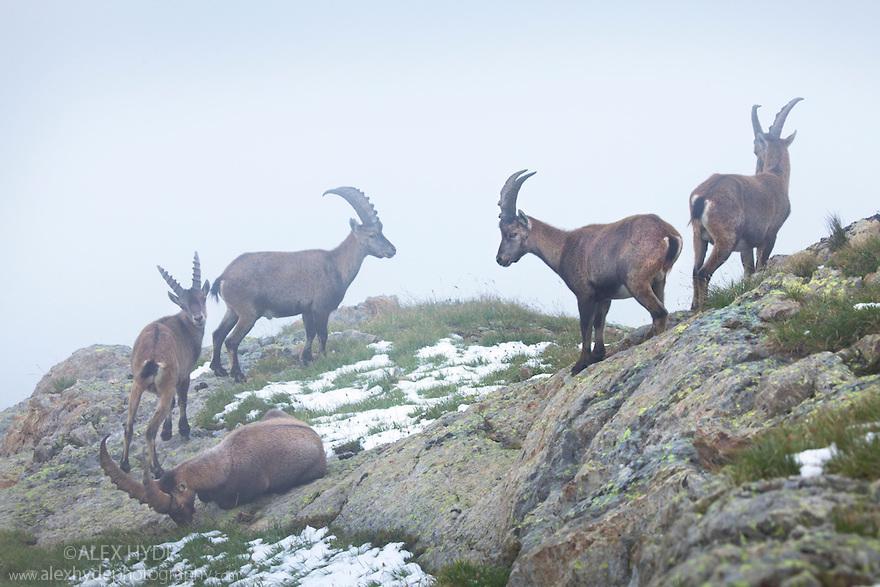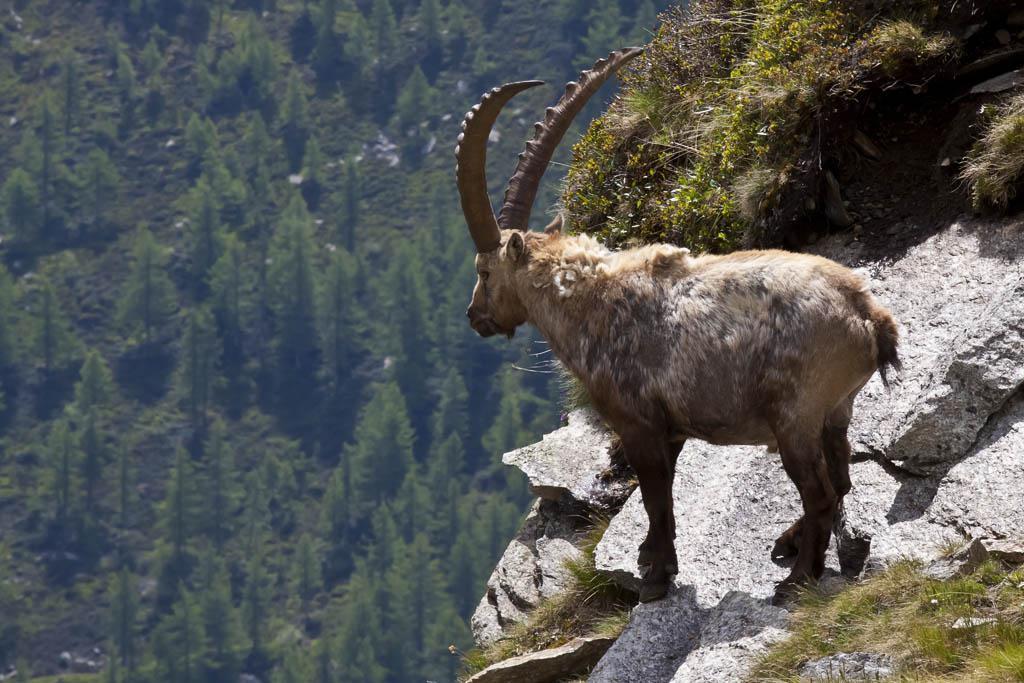The first image is the image on the left, the second image is the image on the right. Examine the images to the left and right. Is the description "The right image contains exactly one mountain goat on a rocky cliff." accurate? Answer yes or no. Yes. The first image is the image on the left, the second image is the image on the right. Considering the images on both sides, is "There are more rams in the image on the left." valid? Answer yes or no. Yes. The first image is the image on the left, the second image is the image on the right. Assess this claim about the two images: "A mountain goat stands on its hinds legs in front of a similarly colored horned animal.". Correct or not? Answer yes or no. No. The first image is the image on the left, the second image is the image on the right. For the images shown, is this caption "The left image contains exactly two mountain goats." true? Answer yes or no. No. 